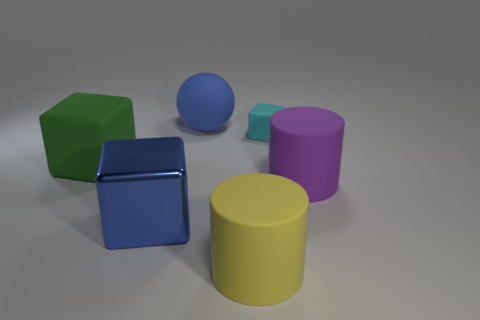Which object appears to be the closest to the viewer in the image? The metallic cube appears to be the closest object to the viewer, as it is more prominent in the foreground and appears larger due to perspective. 